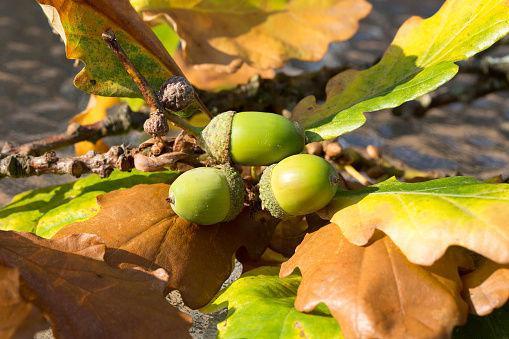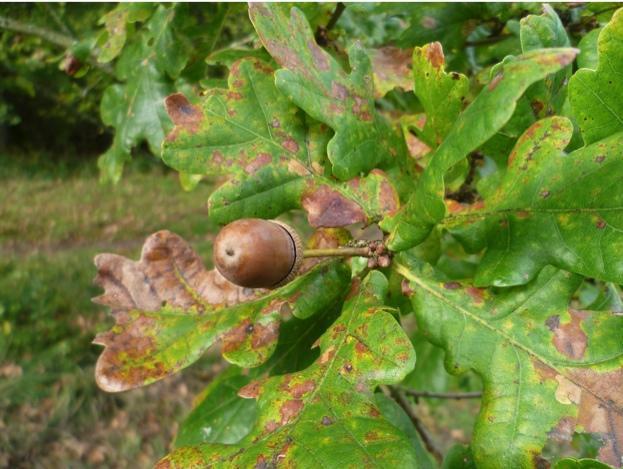The first image is the image on the left, the second image is the image on the right. Considering the images on both sides, is "The left image contains only acorns that are green, and the right image contains only acorns that are brown." valid? Answer yes or no. Yes. The first image is the image on the left, the second image is the image on the right. Evaluate the accuracy of this statement regarding the images: "One image shows a single acorn attached to an oak tree.". Is it true? Answer yes or no. Yes. 